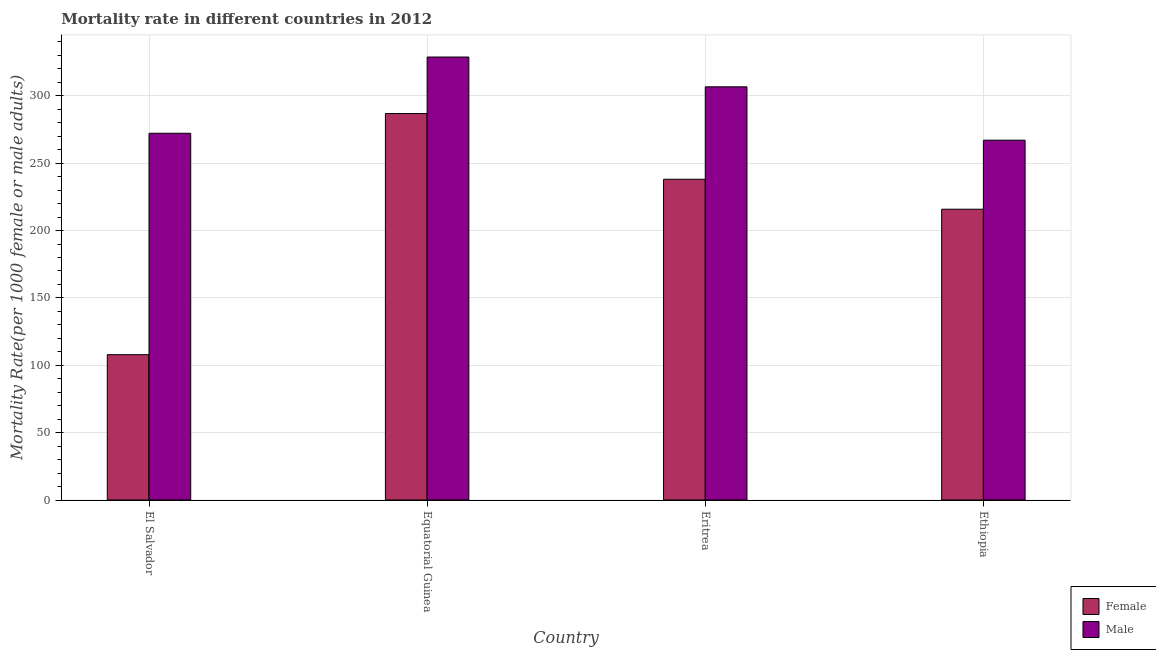How many different coloured bars are there?
Your response must be concise. 2. How many bars are there on the 1st tick from the left?
Ensure brevity in your answer.  2. What is the label of the 2nd group of bars from the left?
Keep it short and to the point. Equatorial Guinea. In how many cases, is the number of bars for a given country not equal to the number of legend labels?
Ensure brevity in your answer.  0. What is the female mortality rate in Ethiopia?
Your answer should be compact. 215.86. Across all countries, what is the maximum female mortality rate?
Provide a short and direct response. 286.88. Across all countries, what is the minimum female mortality rate?
Your answer should be compact. 107.89. In which country was the female mortality rate maximum?
Keep it short and to the point. Equatorial Guinea. In which country was the female mortality rate minimum?
Keep it short and to the point. El Salvador. What is the total male mortality rate in the graph?
Provide a succinct answer. 1174.91. What is the difference between the female mortality rate in Eritrea and that in Ethiopia?
Your response must be concise. 22.26. What is the difference between the female mortality rate in El Salvador and the male mortality rate in Ethiopia?
Ensure brevity in your answer.  -159.2. What is the average male mortality rate per country?
Offer a very short reply. 293.73. What is the difference between the male mortality rate and female mortality rate in Ethiopia?
Offer a very short reply. 51.23. What is the ratio of the female mortality rate in El Salvador to that in Ethiopia?
Your response must be concise. 0.5. Is the difference between the male mortality rate in Eritrea and Ethiopia greater than the difference between the female mortality rate in Eritrea and Ethiopia?
Offer a very short reply. Yes. What is the difference between the highest and the second highest male mortality rate?
Your answer should be very brief. 22.12. What is the difference between the highest and the lowest male mortality rate?
Offer a terse response. 61.75. In how many countries, is the female mortality rate greater than the average female mortality rate taken over all countries?
Keep it short and to the point. 3. What does the 2nd bar from the left in Eritrea represents?
Your response must be concise. Male. What does the 1st bar from the right in El Salvador represents?
Offer a very short reply. Male. Does the graph contain any zero values?
Offer a terse response. No. Does the graph contain grids?
Make the answer very short. Yes. Where does the legend appear in the graph?
Offer a very short reply. Bottom right. How many legend labels are there?
Ensure brevity in your answer.  2. How are the legend labels stacked?
Offer a very short reply. Vertical. What is the title of the graph?
Ensure brevity in your answer.  Mortality rate in different countries in 2012. Does "Residents" appear as one of the legend labels in the graph?
Make the answer very short. No. What is the label or title of the Y-axis?
Give a very brief answer. Mortality Rate(per 1000 female or male adults). What is the Mortality Rate(per 1000 female or male adults) of Female in El Salvador?
Keep it short and to the point. 107.89. What is the Mortality Rate(per 1000 female or male adults) of Male in El Salvador?
Your response must be concise. 272.25. What is the Mortality Rate(per 1000 female or male adults) in Female in Equatorial Guinea?
Offer a very short reply. 286.88. What is the Mortality Rate(per 1000 female or male adults) in Male in Equatorial Guinea?
Ensure brevity in your answer.  328.84. What is the Mortality Rate(per 1000 female or male adults) of Female in Eritrea?
Keep it short and to the point. 238.12. What is the Mortality Rate(per 1000 female or male adults) in Male in Eritrea?
Give a very brief answer. 306.73. What is the Mortality Rate(per 1000 female or male adults) of Female in Ethiopia?
Ensure brevity in your answer.  215.86. What is the Mortality Rate(per 1000 female or male adults) of Male in Ethiopia?
Make the answer very short. 267.1. Across all countries, what is the maximum Mortality Rate(per 1000 female or male adults) in Female?
Your answer should be very brief. 286.88. Across all countries, what is the maximum Mortality Rate(per 1000 female or male adults) of Male?
Ensure brevity in your answer.  328.84. Across all countries, what is the minimum Mortality Rate(per 1000 female or male adults) of Female?
Provide a short and direct response. 107.89. Across all countries, what is the minimum Mortality Rate(per 1000 female or male adults) of Male?
Provide a succinct answer. 267.1. What is the total Mortality Rate(per 1000 female or male adults) in Female in the graph?
Provide a succinct answer. 848.76. What is the total Mortality Rate(per 1000 female or male adults) of Male in the graph?
Offer a very short reply. 1174.91. What is the difference between the Mortality Rate(per 1000 female or male adults) of Female in El Salvador and that in Equatorial Guinea?
Your answer should be compact. -178.99. What is the difference between the Mortality Rate(per 1000 female or male adults) of Male in El Salvador and that in Equatorial Guinea?
Offer a very short reply. -56.6. What is the difference between the Mortality Rate(per 1000 female or male adults) of Female in El Salvador and that in Eritrea?
Ensure brevity in your answer.  -130.22. What is the difference between the Mortality Rate(per 1000 female or male adults) in Male in El Salvador and that in Eritrea?
Give a very brief answer. -34.48. What is the difference between the Mortality Rate(per 1000 female or male adults) in Female in El Salvador and that in Ethiopia?
Make the answer very short. -107.97. What is the difference between the Mortality Rate(per 1000 female or male adults) in Male in El Salvador and that in Ethiopia?
Make the answer very short. 5.15. What is the difference between the Mortality Rate(per 1000 female or male adults) of Female in Equatorial Guinea and that in Eritrea?
Make the answer very short. 48.77. What is the difference between the Mortality Rate(per 1000 female or male adults) in Male in Equatorial Guinea and that in Eritrea?
Provide a short and direct response. 22.11. What is the difference between the Mortality Rate(per 1000 female or male adults) in Female in Equatorial Guinea and that in Ethiopia?
Your response must be concise. 71.02. What is the difference between the Mortality Rate(per 1000 female or male adults) of Male in Equatorial Guinea and that in Ethiopia?
Give a very brief answer. 61.75. What is the difference between the Mortality Rate(per 1000 female or male adults) of Female in Eritrea and that in Ethiopia?
Provide a short and direct response. 22.26. What is the difference between the Mortality Rate(per 1000 female or male adults) of Male in Eritrea and that in Ethiopia?
Offer a terse response. 39.63. What is the difference between the Mortality Rate(per 1000 female or male adults) in Female in El Salvador and the Mortality Rate(per 1000 female or male adults) in Male in Equatorial Guinea?
Offer a terse response. -220.95. What is the difference between the Mortality Rate(per 1000 female or male adults) of Female in El Salvador and the Mortality Rate(per 1000 female or male adults) of Male in Eritrea?
Offer a terse response. -198.83. What is the difference between the Mortality Rate(per 1000 female or male adults) of Female in El Salvador and the Mortality Rate(per 1000 female or male adults) of Male in Ethiopia?
Provide a short and direct response. -159.2. What is the difference between the Mortality Rate(per 1000 female or male adults) in Female in Equatorial Guinea and the Mortality Rate(per 1000 female or male adults) in Male in Eritrea?
Offer a terse response. -19.84. What is the difference between the Mortality Rate(per 1000 female or male adults) of Female in Equatorial Guinea and the Mortality Rate(per 1000 female or male adults) of Male in Ethiopia?
Give a very brief answer. 19.79. What is the difference between the Mortality Rate(per 1000 female or male adults) of Female in Eritrea and the Mortality Rate(per 1000 female or male adults) of Male in Ethiopia?
Make the answer very short. -28.98. What is the average Mortality Rate(per 1000 female or male adults) of Female per country?
Your response must be concise. 212.19. What is the average Mortality Rate(per 1000 female or male adults) in Male per country?
Your response must be concise. 293.73. What is the difference between the Mortality Rate(per 1000 female or male adults) of Female and Mortality Rate(per 1000 female or male adults) of Male in El Salvador?
Provide a short and direct response. -164.35. What is the difference between the Mortality Rate(per 1000 female or male adults) in Female and Mortality Rate(per 1000 female or male adults) in Male in Equatorial Guinea?
Keep it short and to the point. -41.96. What is the difference between the Mortality Rate(per 1000 female or male adults) of Female and Mortality Rate(per 1000 female or male adults) of Male in Eritrea?
Give a very brief answer. -68.61. What is the difference between the Mortality Rate(per 1000 female or male adults) in Female and Mortality Rate(per 1000 female or male adults) in Male in Ethiopia?
Your answer should be compact. -51.23. What is the ratio of the Mortality Rate(per 1000 female or male adults) in Female in El Salvador to that in Equatorial Guinea?
Your answer should be compact. 0.38. What is the ratio of the Mortality Rate(per 1000 female or male adults) of Male in El Salvador to that in Equatorial Guinea?
Keep it short and to the point. 0.83. What is the ratio of the Mortality Rate(per 1000 female or male adults) of Female in El Salvador to that in Eritrea?
Your answer should be very brief. 0.45. What is the ratio of the Mortality Rate(per 1000 female or male adults) in Male in El Salvador to that in Eritrea?
Keep it short and to the point. 0.89. What is the ratio of the Mortality Rate(per 1000 female or male adults) in Female in El Salvador to that in Ethiopia?
Your answer should be very brief. 0.5. What is the ratio of the Mortality Rate(per 1000 female or male adults) of Male in El Salvador to that in Ethiopia?
Offer a very short reply. 1.02. What is the ratio of the Mortality Rate(per 1000 female or male adults) in Female in Equatorial Guinea to that in Eritrea?
Offer a terse response. 1.2. What is the ratio of the Mortality Rate(per 1000 female or male adults) in Male in Equatorial Guinea to that in Eritrea?
Your answer should be compact. 1.07. What is the ratio of the Mortality Rate(per 1000 female or male adults) in Female in Equatorial Guinea to that in Ethiopia?
Keep it short and to the point. 1.33. What is the ratio of the Mortality Rate(per 1000 female or male adults) of Male in Equatorial Guinea to that in Ethiopia?
Your answer should be very brief. 1.23. What is the ratio of the Mortality Rate(per 1000 female or male adults) of Female in Eritrea to that in Ethiopia?
Keep it short and to the point. 1.1. What is the ratio of the Mortality Rate(per 1000 female or male adults) of Male in Eritrea to that in Ethiopia?
Offer a terse response. 1.15. What is the difference between the highest and the second highest Mortality Rate(per 1000 female or male adults) in Female?
Give a very brief answer. 48.77. What is the difference between the highest and the second highest Mortality Rate(per 1000 female or male adults) in Male?
Give a very brief answer. 22.11. What is the difference between the highest and the lowest Mortality Rate(per 1000 female or male adults) of Female?
Your answer should be compact. 178.99. What is the difference between the highest and the lowest Mortality Rate(per 1000 female or male adults) in Male?
Make the answer very short. 61.75. 